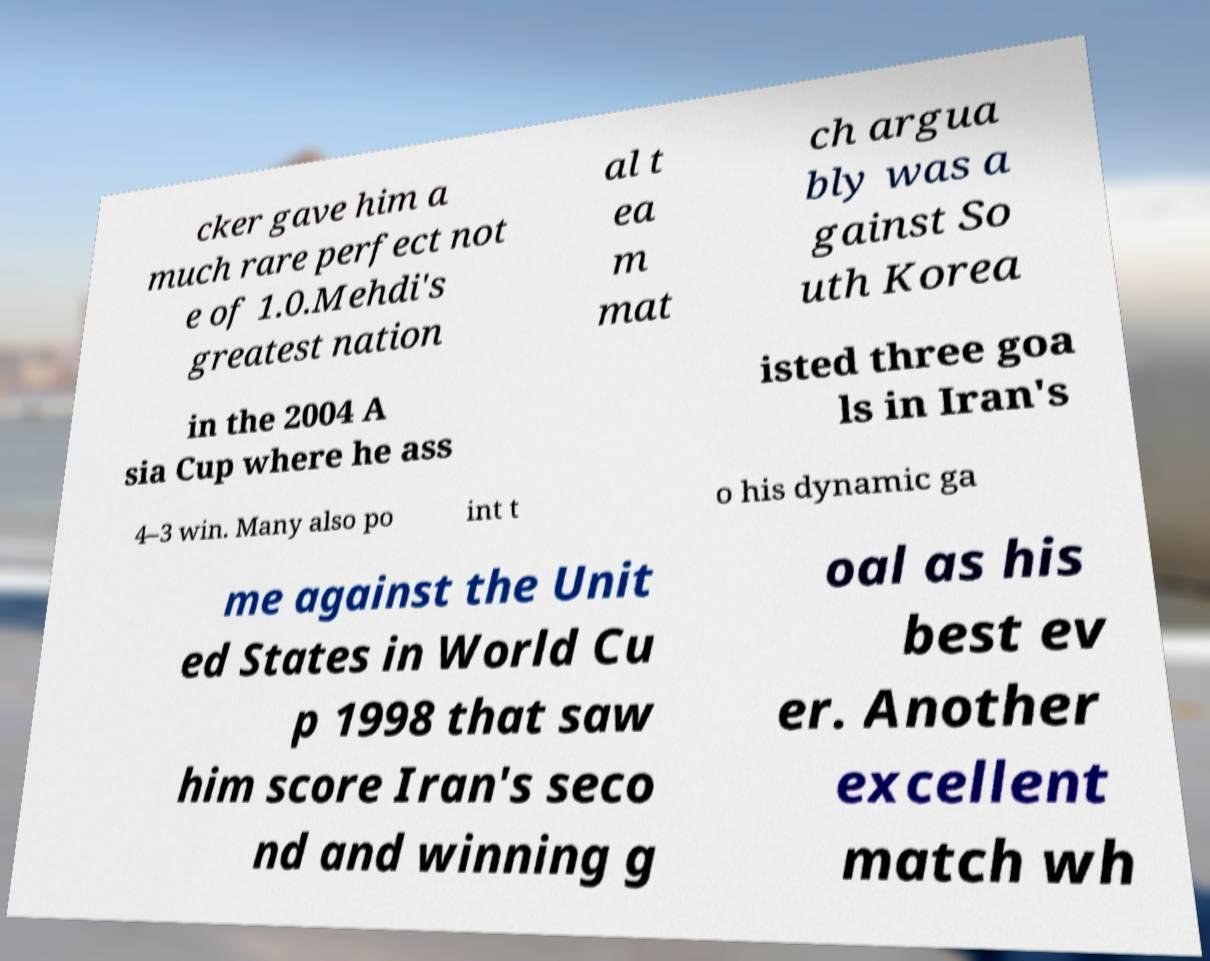Can you read and provide the text displayed in the image?This photo seems to have some interesting text. Can you extract and type it out for me? cker gave him a much rare perfect not e of 1.0.Mehdi's greatest nation al t ea m mat ch argua bly was a gainst So uth Korea in the 2004 A sia Cup where he ass isted three goa ls in Iran's 4–3 win. Many also po int t o his dynamic ga me against the Unit ed States in World Cu p 1998 that saw him score Iran's seco nd and winning g oal as his best ev er. Another excellent match wh 